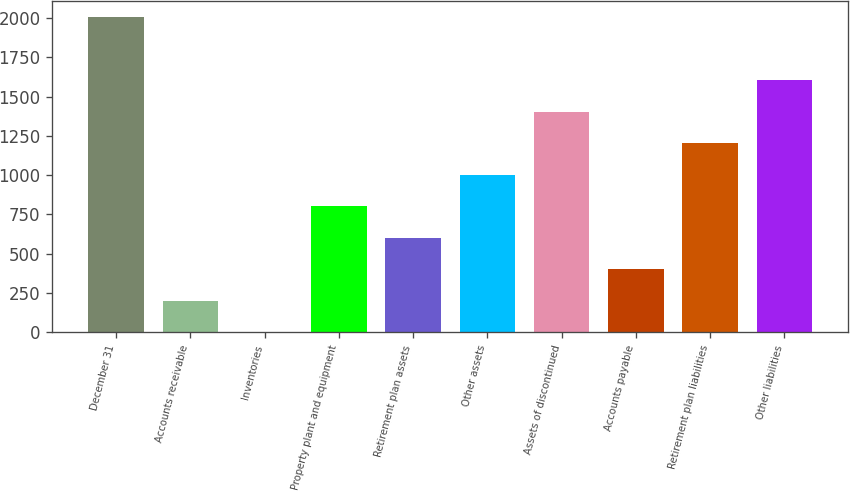Convert chart to OTSL. <chart><loc_0><loc_0><loc_500><loc_500><bar_chart><fcel>December 31<fcel>Accounts receivable<fcel>Inventories<fcel>Property plant and equipment<fcel>Retirement plan assets<fcel>Other assets<fcel>Assets of discontinued<fcel>Accounts payable<fcel>Retirement plan liabilities<fcel>Other liabilities<nl><fcel>2006<fcel>201.5<fcel>1<fcel>803<fcel>602.5<fcel>1003.5<fcel>1404.5<fcel>402<fcel>1204<fcel>1605<nl></chart> 